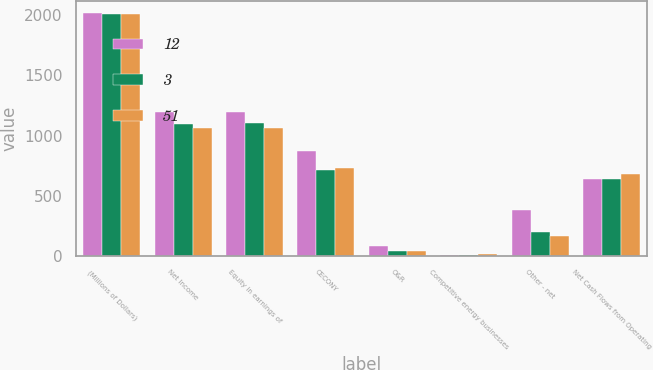Convert chart. <chart><loc_0><loc_0><loc_500><loc_500><stacked_bar_chart><ecel><fcel>(Millions of Dollars)<fcel>Net Income<fcel>Equity in earnings of<fcel>CECONY<fcel>O&R<fcel>Competitive energy businesses<fcel>Other - net<fcel>Net Cash Flows from Operating<nl><fcel>12<fcel>2015<fcel>1193<fcel>1195<fcel>872<fcel>81<fcel>8<fcel>382<fcel>635<nl><fcel>3<fcel>2014<fcel>1092<fcel>1101<fcel>712<fcel>40<fcel>8<fcel>199<fcel>642<nl><fcel>51<fcel>2013<fcel>1062<fcel>1062<fcel>728<fcel>38<fcel>12<fcel>166<fcel>680<nl></chart> 